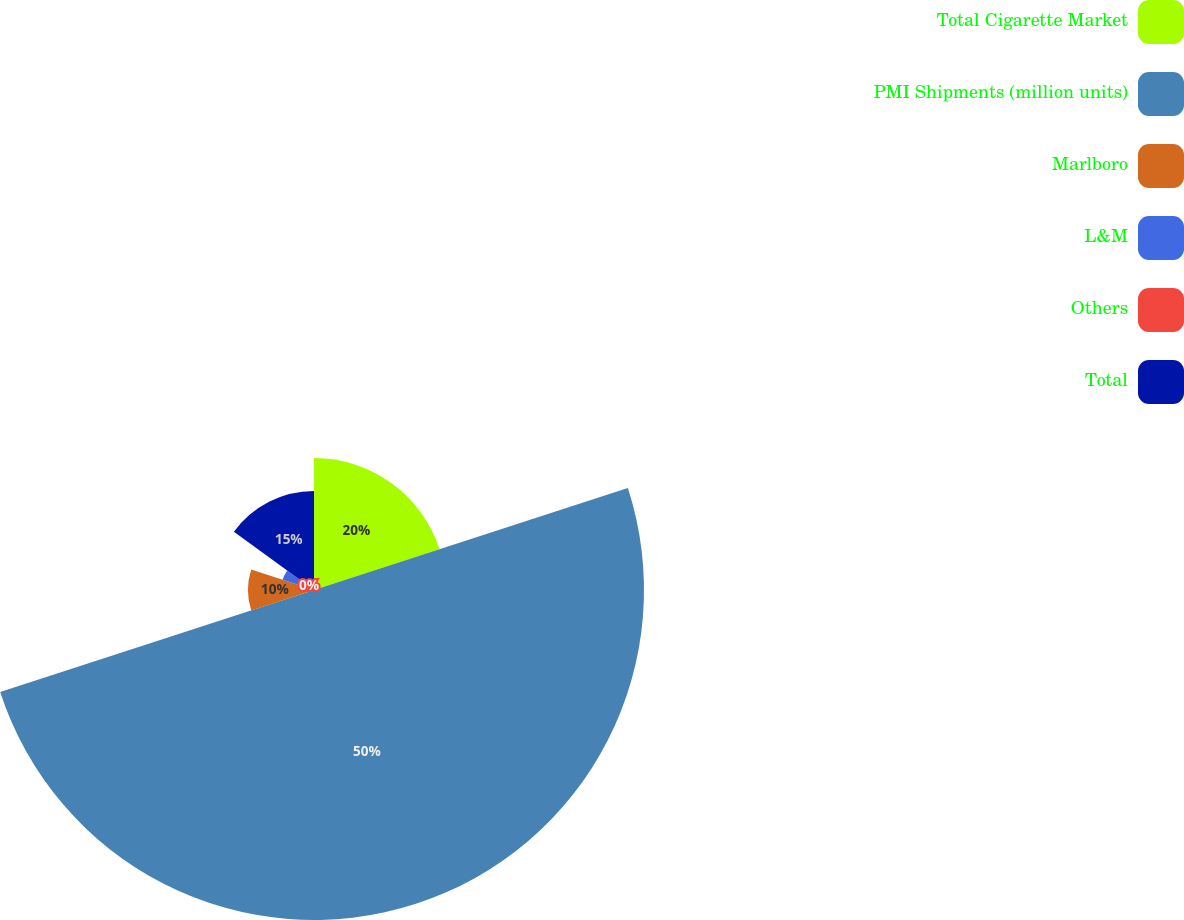Convert chart to OTSL. <chart><loc_0><loc_0><loc_500><loc_500><pie_chart><fcel>Total Cigarette Market<fcel>PMI Shipments (million units)<fcel>Marlboro<fcel>L&M<fcel>Others<fcel>Total<nl><fcel>20.0%<fcel>49.99%<fcel>10.0%<fcel>5.0%<fcel>0.0%<fcel>15.0%<nl></chart> 